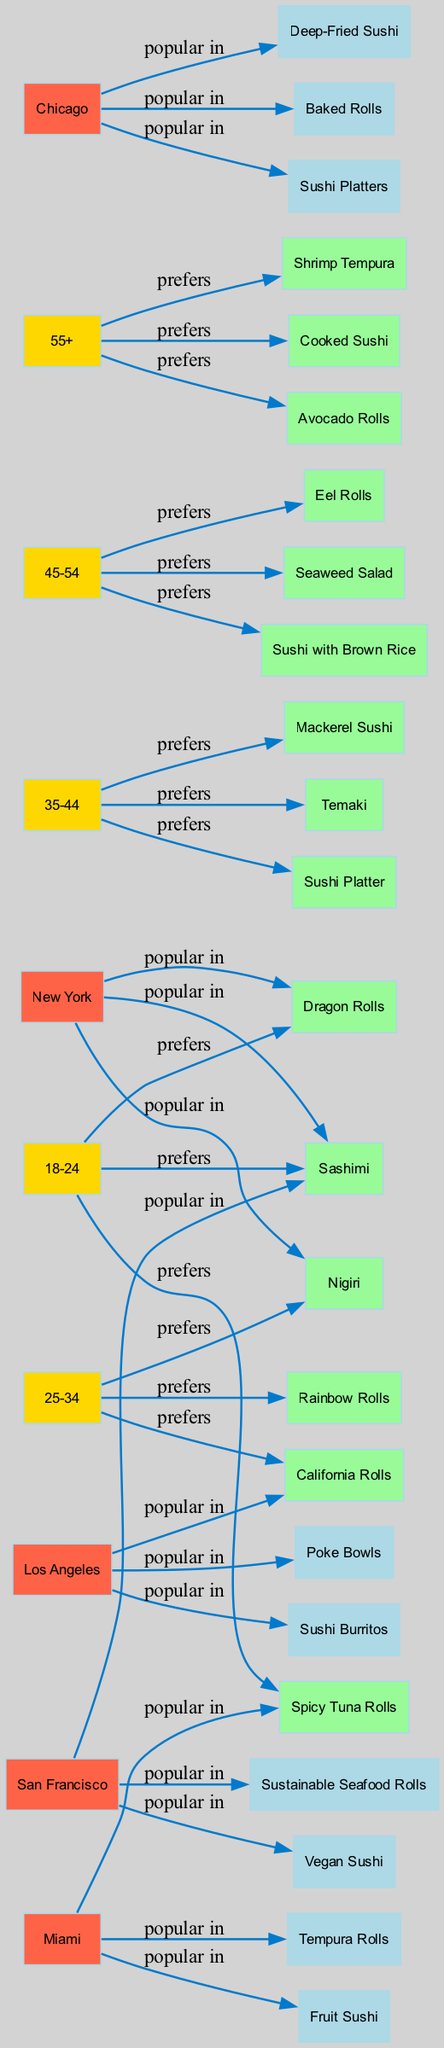What are the most popular sushi types among the 18-24 age group? By looking at the age group node for 18-24, we can see the preferences connected from this node, which are Spicy Tuna Rolls, Dragon Rolls, and Sashimi.
Answer: Spicy Tuna Rolls, Dragon Rolls, Sashimi Which sushi type is popular in Los Angeles? In the diagram, we can identify the edge connected from the Los Angeles node to its popular sushi types, which are California Rolls, Poke Bowls, and Sushi Burritos.
Answer: California Rolls, Poke Bowls, Sushi Burritos How many age groups are present in the diagram? Counting the nodes for age groups, there are five distinct age group nodes, which represent different ranges from 18-24 to 55+.
Answer: 5 Which sushi type is preferred by the 45-54 age group? The diagram shows the edge connecting the 45-54 age group node to its preferences, which include Eel Rolls, Seaweed Salad, and Sushi with Brown Rice.
Answer: Eel Rolls, Seaweed Salad, Sushi with Brown Rice What is the primary sushi type preference of the 35-44 age group compared to the 25-34 age group? For the 35-44 age group, the preferences are Mackerel Sushi, Temaki, and Sushi Platter; for the 25-34 age group, the preferences are California Rolls, Rainbow Rolls, and Nigiri. The significant difference lies between Mackerel Sushi and California Rolls.
Answer: Mackerel Sushi and California Rolls Which city favors Shrimp Tempura? Reviewing the city nodes, Shrimp Tempura is listed under the popular sushi types for the 55+ age group, but it is not popular in any of the given cities, indicating that it may be less favored amongst the locations.
Answer: Not favored in any city Which age group has the highest tendency towards sushi platters? The diagram reveals that the 35-44 age group prefers sushi platters among their choices. This means that for sushi platters, that particular age group's preference is significant.
Answer: 35-44 How many total sushi types are listed in the diagram? Counting the unique sushi types from preferences and popular types across age groups and locations gives us a total of 14 distinct sushi types.
Answer: 14 Which sushi type is common across all age groups? Analyzing the preferences of all age groups, we find that sushi platters are listed only under the 35-44 age group and do not appear universally across the others, indicating a gap.
Answer: None 